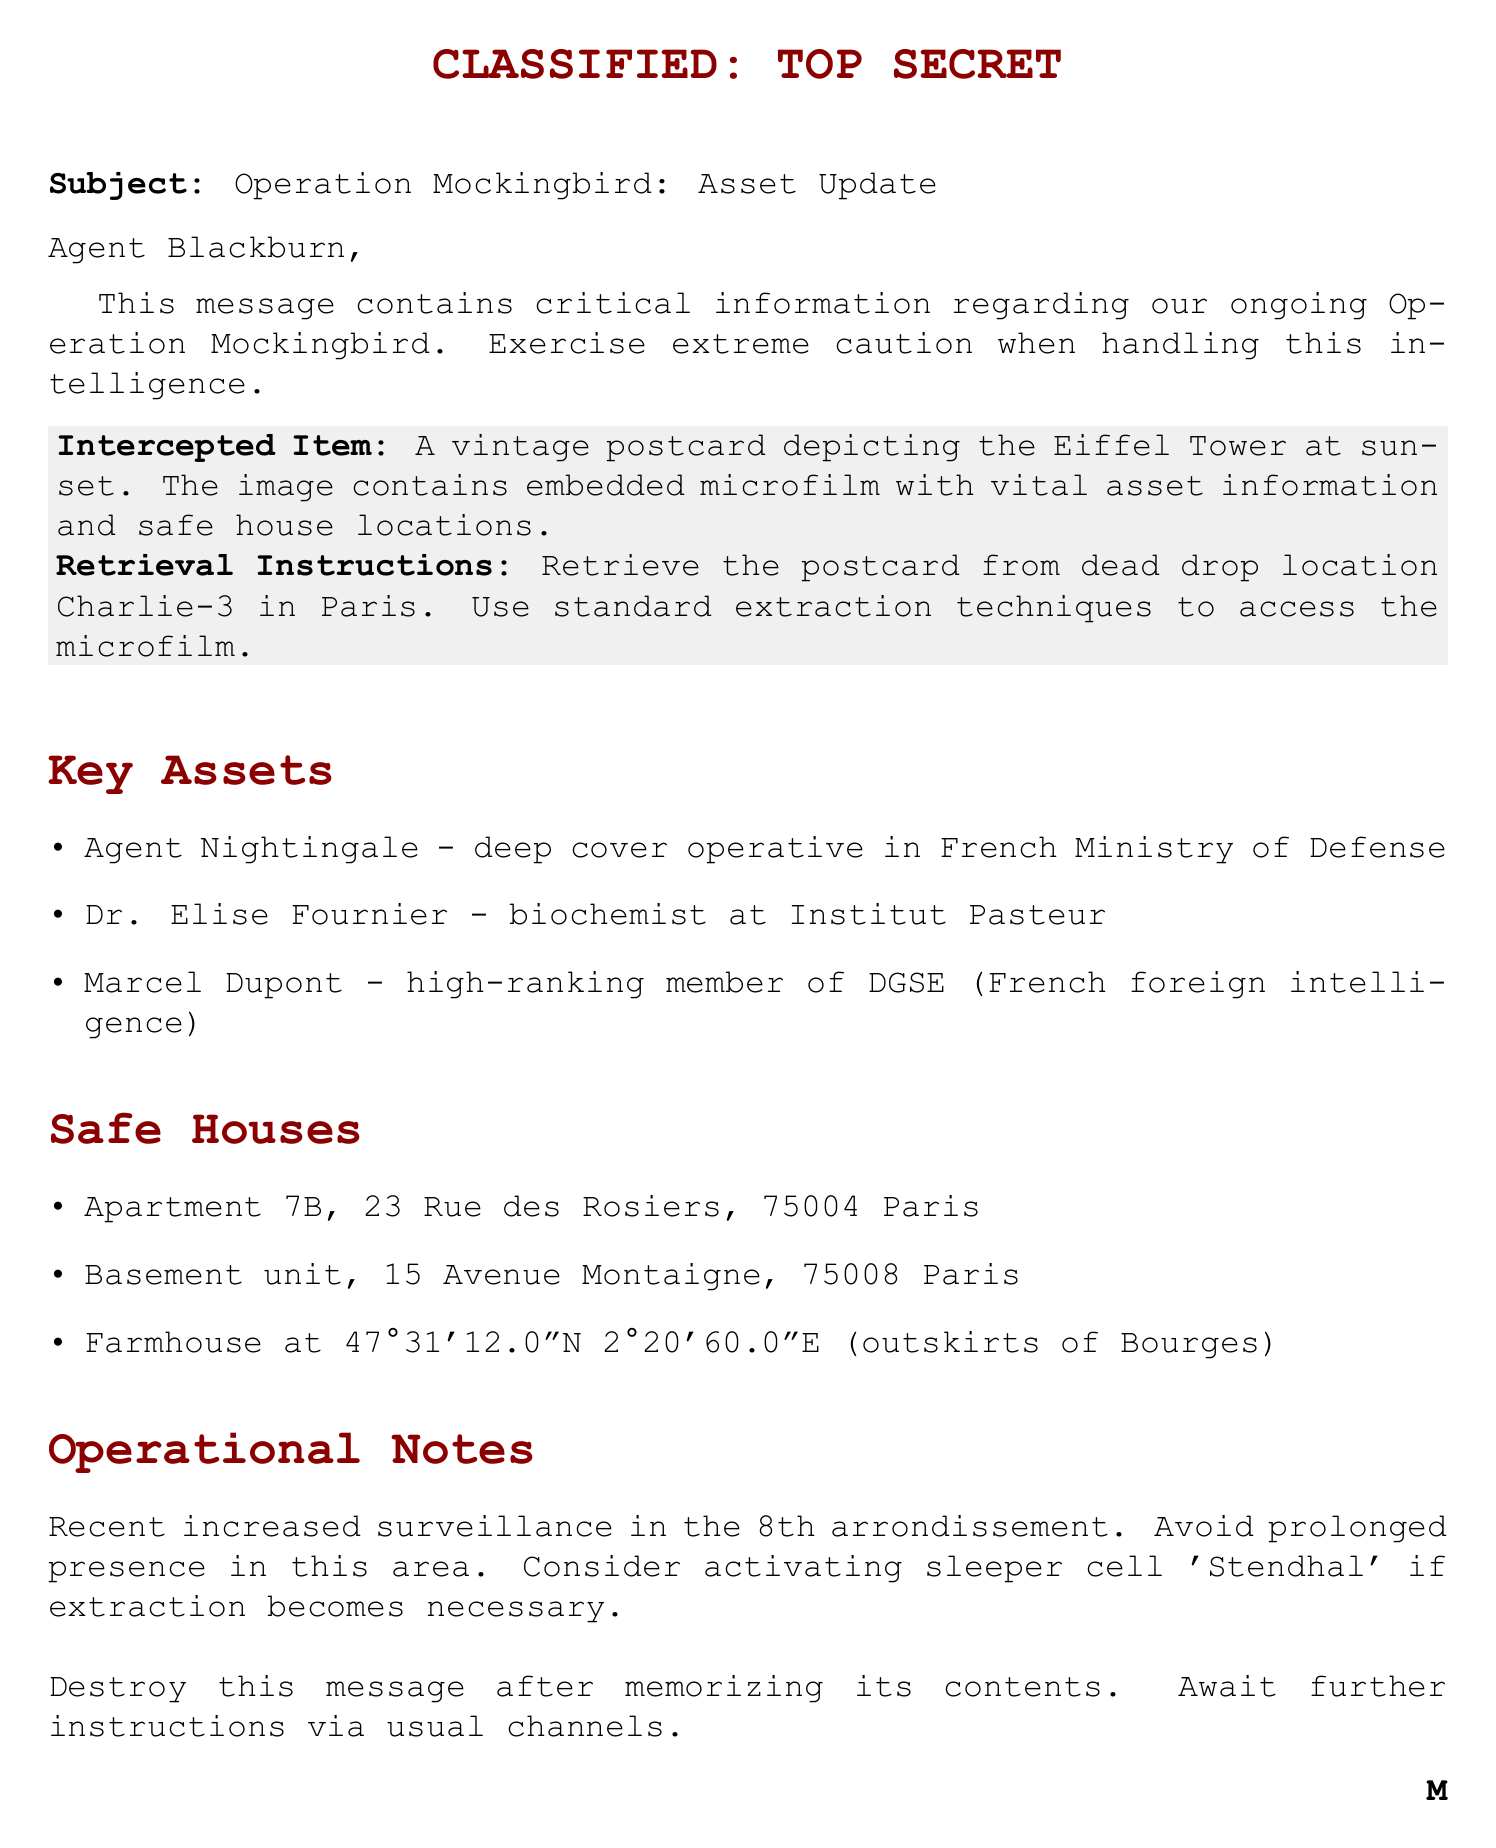What is the subject of the document? The subject line indicates the main focus of the communication, which is the update on Operation Mockingbird.
Answer: Operation Mockingbird: Asset Update Who is the greeting addressed to? The greeting specifies the name of the agent who is receiving this intelligence.
Answer: Agent Blackburn What is the intercepted item mentioned in the document? The postcard's description details the item that contains the critical information.
Answer: A vintage postcard depicting the Eiffel Tower at sunset Where should the postcard be retrieved from? The retrieval instructions outline the location where the postcard can be found.
Answer: dead drop location Charlie-3 in Paris What is the address of one of the safe houses? The safe houses section lists specific addresses where agents can find shelter.
Answer: Apartment 7B, 23 Rue des Rosiers, 75004 Paris What is the operational note regarding surveillance? The operational notes highlight a specific danger that agents need to be aware of during their mission.
Answer: Recent increased surveillance in the 8th arrondissement How many key assets are listed in the document? The key assets section enumerates individuals of interest in the ongoing operation.
Answer: Three What action should be taken after memorizing the message? The closing statement specifies a security measure after the information is retained.
Answer: Destroy this message after memorizing its contents 